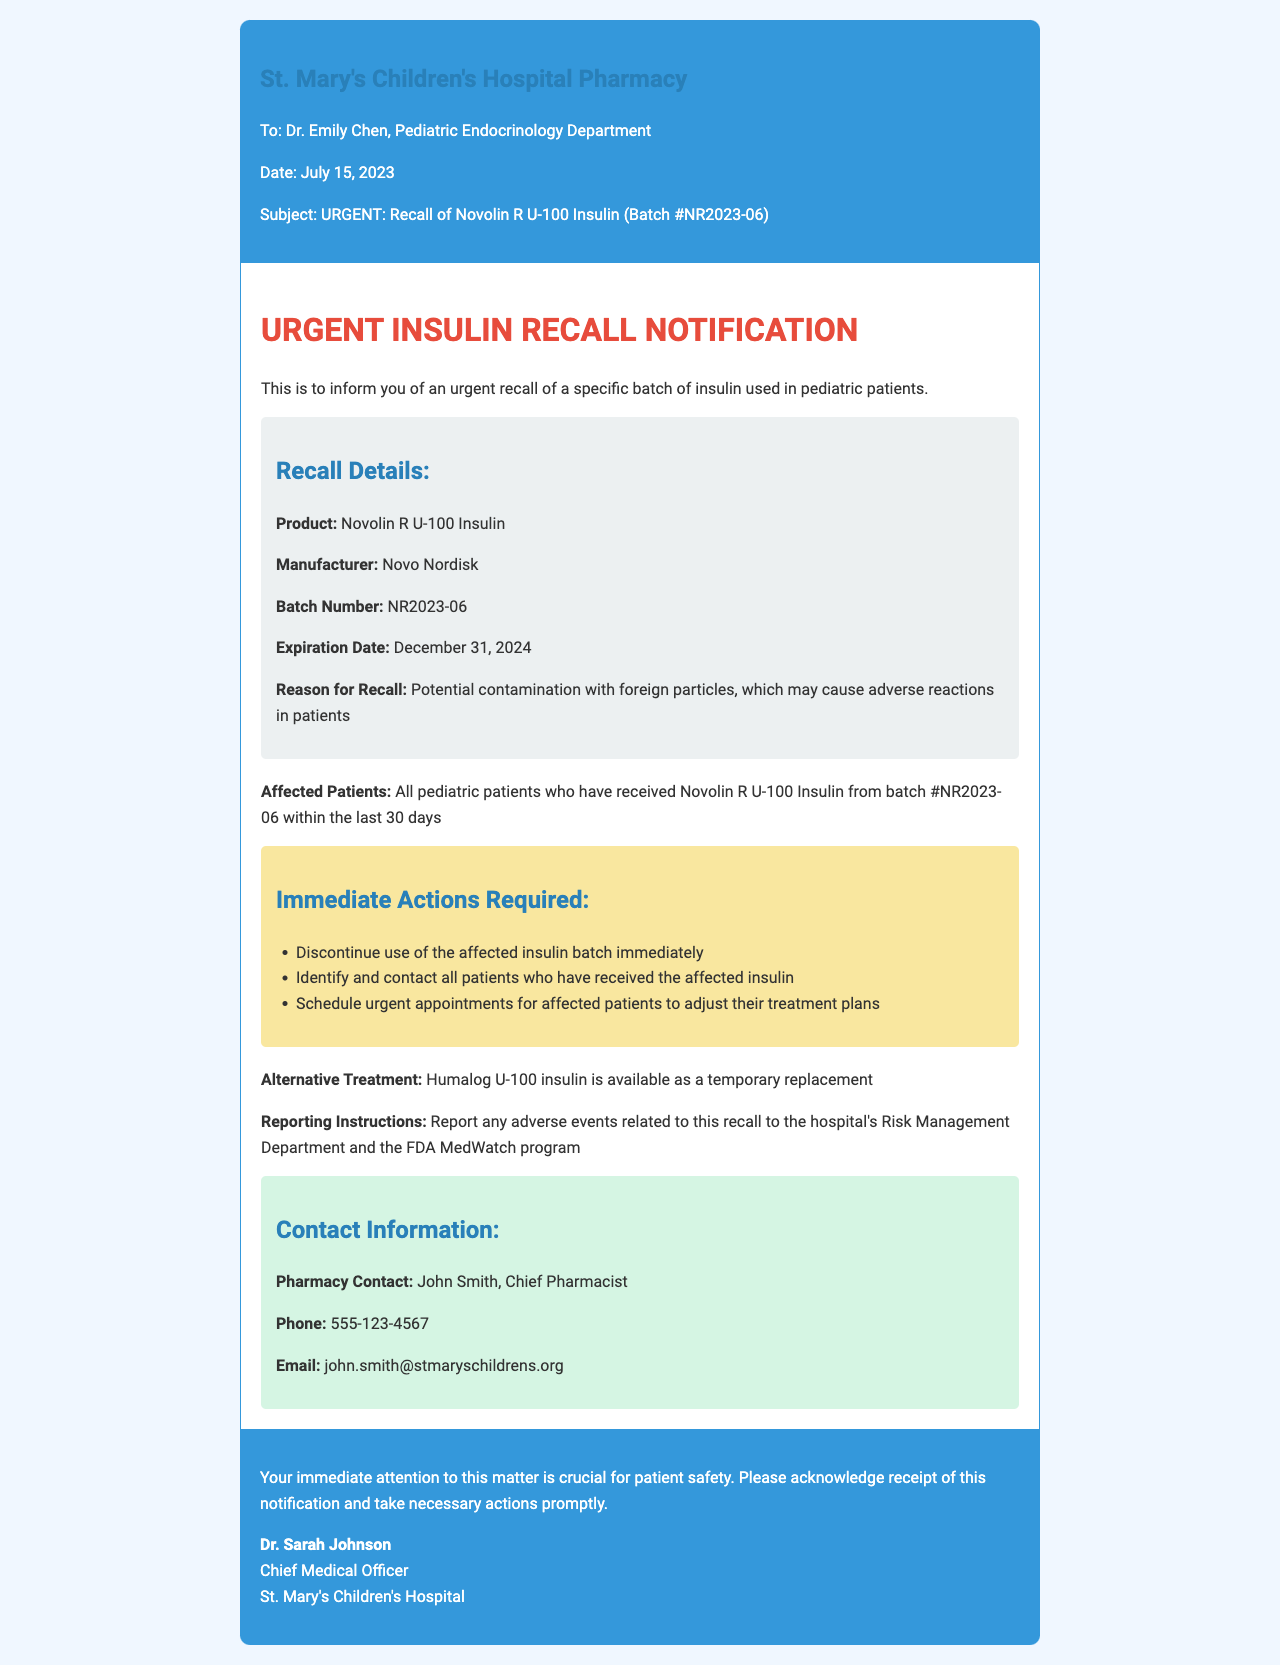What is the product being recalled? The recalled product is specified in the notification under recall details.
Answer: Novolin R U-100 Insulin What is the batch number of the recalled insulin? The batch number is detailed in the recall details section of the document.
Answer: NR2023-06 What is the expiration date of the recalled insulin? The expiration date is provided in the recall details for the insulin batch.
Answer: December 31, 2024 What is the reason for the recall? The reason for recall is mentioned and outlines the issue with the product.
Answer: Potential contamination with foreign particles Who should be contacted regarding this recall? The document specifies the contact person in the contact information section.
Answer: John Smith, Chief Pharmacist What is the alternative treatment suggested? The document provides a recommendation for an alternative treatment in the actions section.
Answer: Humalog U-100 insulin How many days prior to the notification are affected patients considered? The document specifies the time frame in which the patients received the affected product.
Answer: 30 days What actions are required from the medical staff? The actions required are listed in the actions section of the notification.
Answer: Discontinue use of the affected insulin batch immediately What type of document is this? The header of the document indicates its classification clearly.
Answer: Fax 